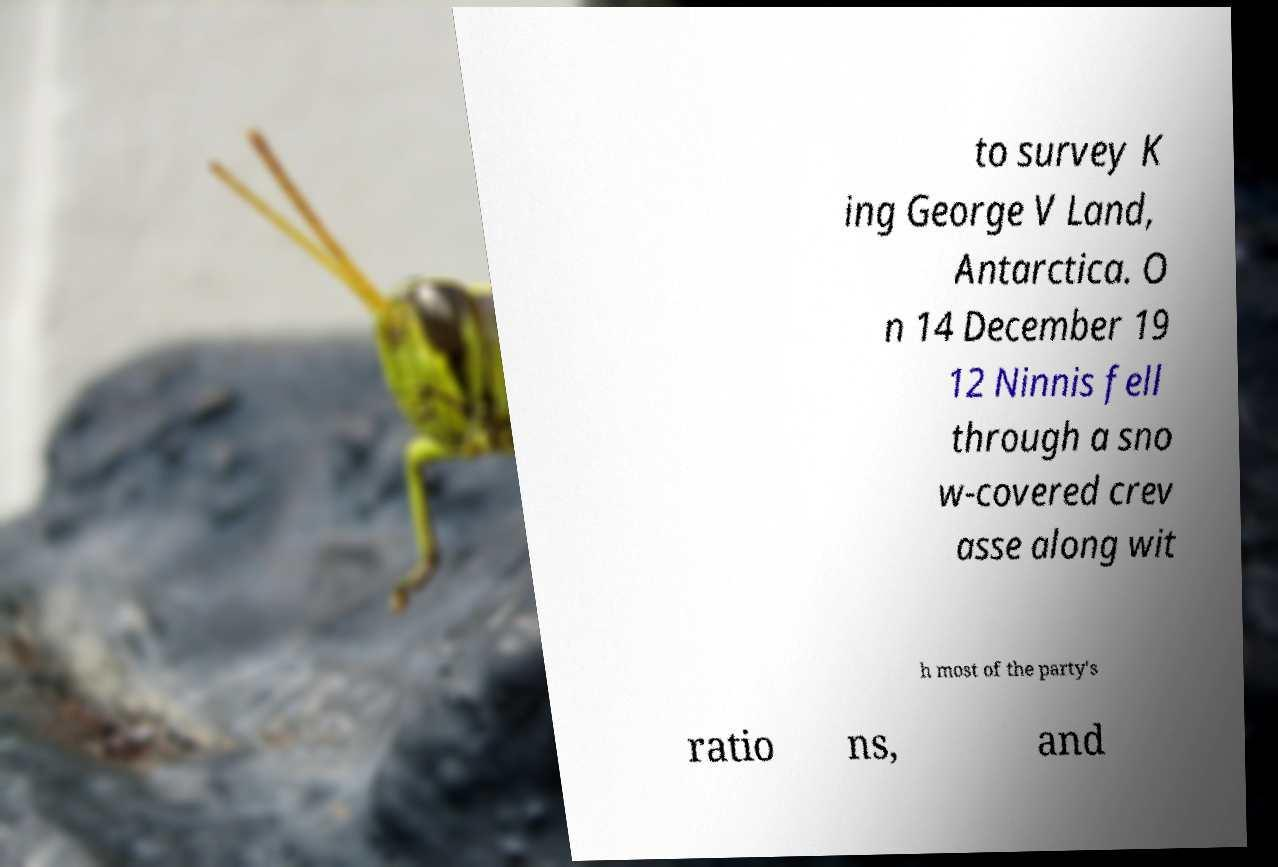Could you assist in decoding the text presented in this image and type it out clearly? to survey K ing George V Land, Antarctica. O n 14 December 19 12 Ninnis fell through a sno w-covered crev asse along wit h most of the party's ratio ns, and 